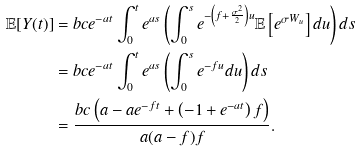Convert formula to latex. <formula><loc_0><loc_0><loc_500><loc_500>\mathbb { E } [ Y ( t ) ] & = b c e ^ { - a t } \int _ { 0 } ^ { t } e ^ { a s } \left ( \int _ { 0 } ^ { s } e ^ { - \left ( f + \frac { \sigma ^ { 2 } } { 2 } \right ) u } \mathbb { E } \left [ e ^ { \sigma W _ { u } } \right ] d u \right ) d s \\ & = b c e ^ { - a t } \int _ { 0 } ^ { t } e ^ { a s } \left ( \int _ { 0 } ^ { s } e ^ { - f u } d u \right ) d s \\ & = \frac { b c \left ( a - a e ^ { - f t } + \left ( - 1 + e ^ { - a t } \right ) f \right ) } { a ( a - f ) f } .</formula> 